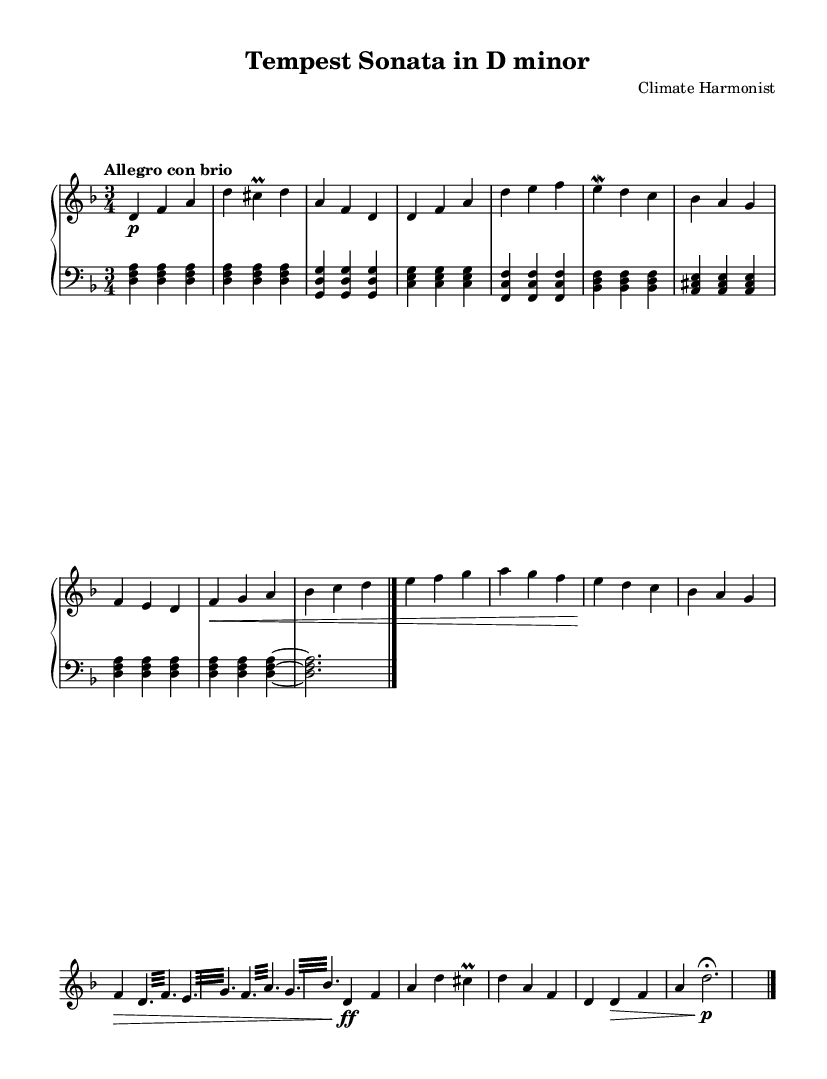What is the key signature of this music? The key signature is two flats, indicating that it is in D minor, which is the relative minor of F major.
Answer: D minor What is the time signature of this piece? The time signature is indicated as 3/4, meaning there are three beats in each measure and a quarter note receives one beat.
Answer: 3/4 What is the tempo marking for this composition? The tempo marking is "Allegro con brio," which indicates a lively and vigorous pace.
Answer: Allegro con brio How many measures are in the introduction section? The introduction consists of three measures, which is evident from the counting of the bars in the sheet music.
Answer: 3 What musical device is predominantly used during the development section? The development section features a tremolo, which is a rapid alternation of two notes and is indicated by the instruction “\repeat tremolo” in the score.
Answer: Tremolo What are the main themes labeled in the music? The themes are labeled as Theme A (Calm before the storm) and Theme B (Rising winds), highlighting the contrasting musical ideas inspired by weather patterns.
Answer: Theme A and Theme B What is the final dynamic marking in the coda? The final dynamic marking is p, indicating a soft ending to the piece as the storm subsides.
Answer: p 